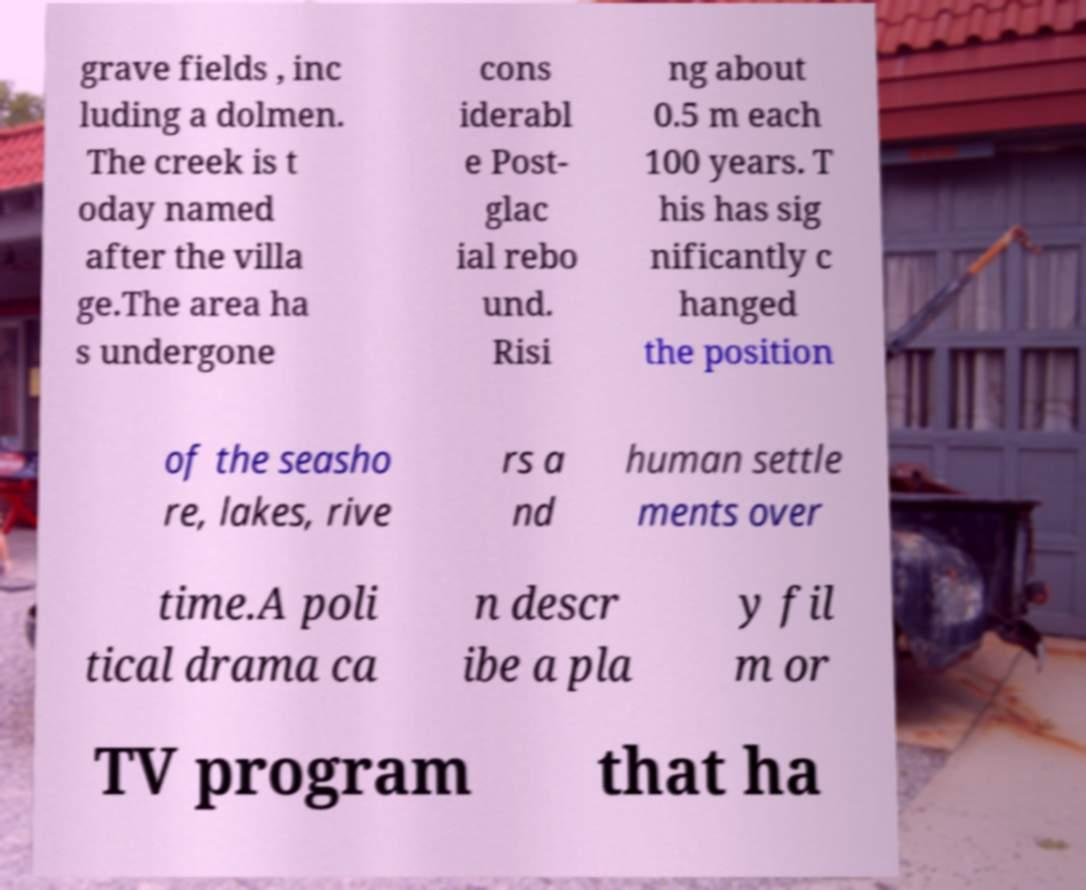There's text embedded in this image that I need extracted. Can you transcribe it verbatim? grave fields , inc luding a dolmen. The creek is t oday named after the villa ge.The area ha s undergone cons iderabl e Post- glac ial rebo und. Risi ng about 0.5 m each 100 years. T his has sig nificantly c hanged the position of the seasho re, lakes, rive rs a nd human settle ments over time.A poli tical drama ca n descr ibe a pla y fil m or TV program that ha 